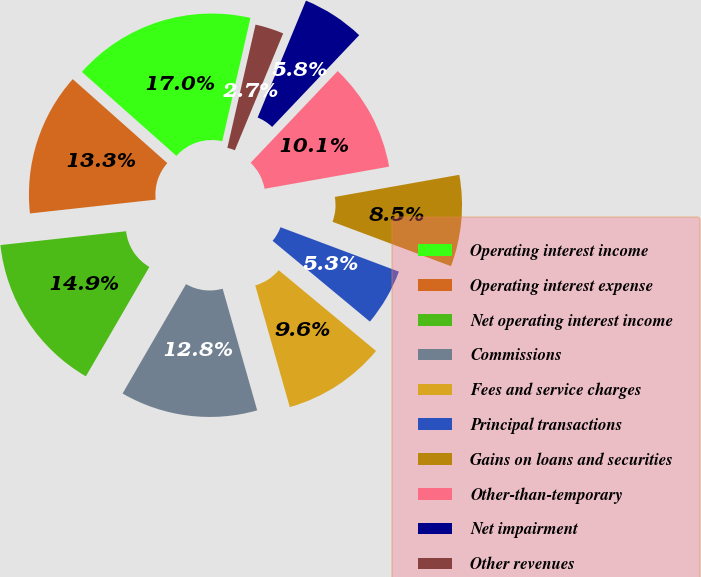Convert chart to OTSL. <chart><loc_0><loc_0><loc_500><loc_500><pie_chart><fcel>Operating interest income<fcel>Operating interest expense<fcel>Net operating interest income<fcel>Commissions<fcel>Fees and service charges<fcel>Principal transactions<fcel>Gains on loans and securities<fcel>Other-than-temporary<fcel>Net impairment<fcel>Other revenues<nl><fcel>17.02%<fcel>13.3%<fcel>14.89%<fcel>12.77%<fcel>9.57%<fcel>5.32%<fcel>8.51%<fcel>10.11%<fcel>5.85%<fcel>2.66%<nl></chart> 